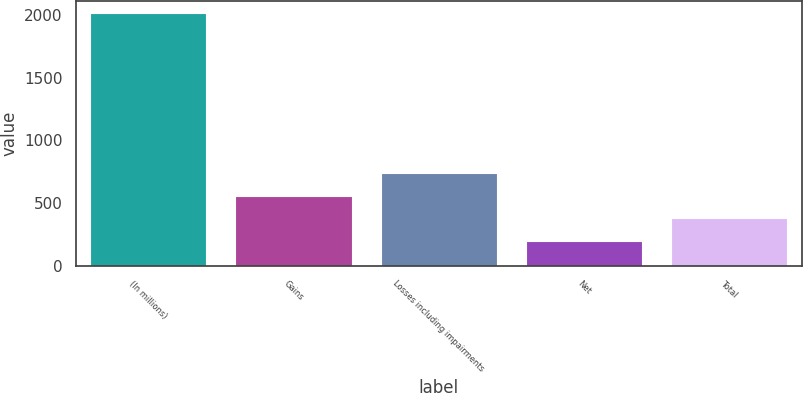Convert chart. <chart><loc_0><loc_0><loc_500><loc_500><bar_chart><fcel>(In millions)<fcel>Gains<fcel>Losses including impairments<fcel>Net<fcel>Total<nl><fcel>2011<fcel>559.8<fcel>741.2<fcel>197<fcel>378.4<nl></chart> 